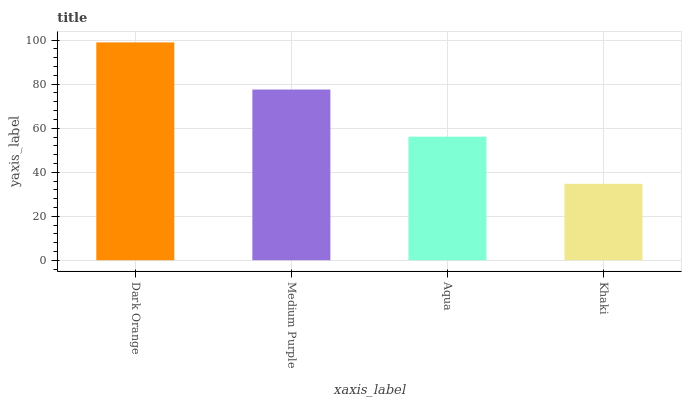Is Khaki the minimum?
Answer yes or no. Yes. Is Dark Orange the maximum?
Answer yes or no. Yes. Is Medium Purple the minimum?
Answer yes or no. No. Is Medium Purple the maximum?
Answer yes or no. No. Is Dark Orange greater than Medium Purple?
Answer yes or no. Yes. Is Medium Purple less than Dark Orange?
Answer yes or no. Yes. Is Medium Purple greater than Dark Orange?
Answer yes or no. No. Is Dark Orange less than Medium Purple?
Answer yes or no. No. Is Medium Purple the high median?
Answer yes or no. Yes. Is Aqua the low median?
Answer yes or no. Yes. Is Aqua the high median?
Answer yes or no. No. Is Dark Orange the low median?
Answer yes or no. No. 